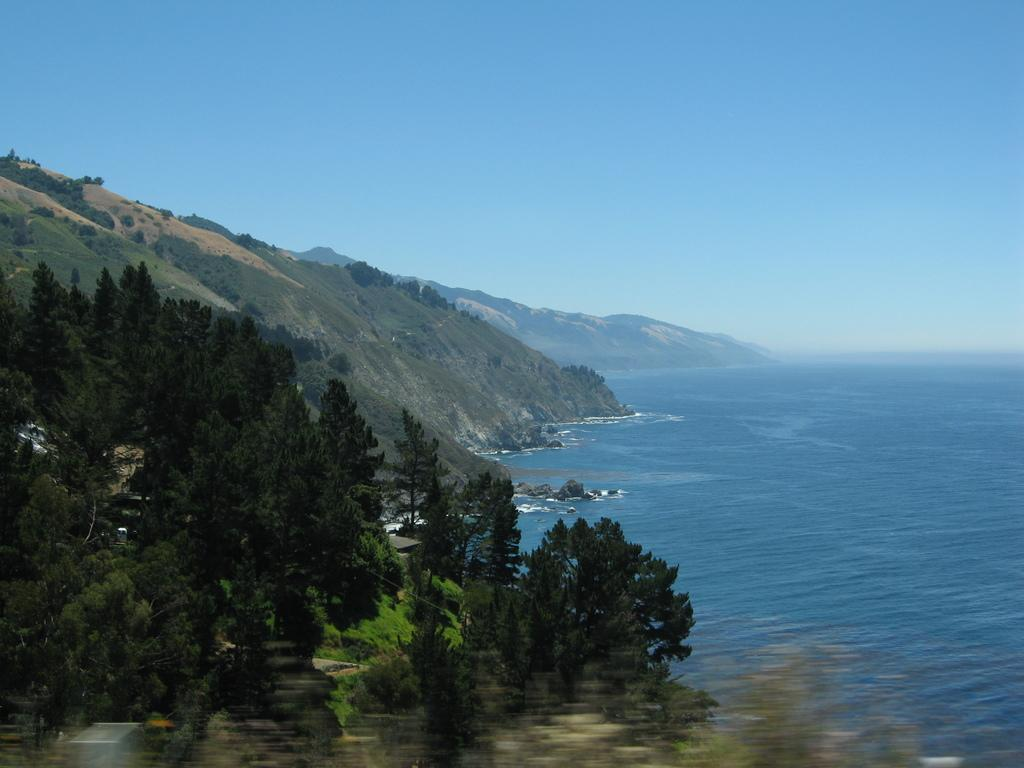What type of vegetation can be seen in the image? There are trees in the image. What can be seen in the distance behind the trees? There are hills visible in the background of the image. What body of water is present in the image? There is an ocean with blue water in the image. What else is visible in the background of the image? The sky is visible in the background of the image. Can you tell me how many socks are floating in the ocean in the image? There are no socks present in the image; it features an ocean with blue water. What type of arithmetic problem is being solved on the hill in the image? There is no arithmetic problem visible in the image; it only shows trees, hills, an ocean, and the sky. 